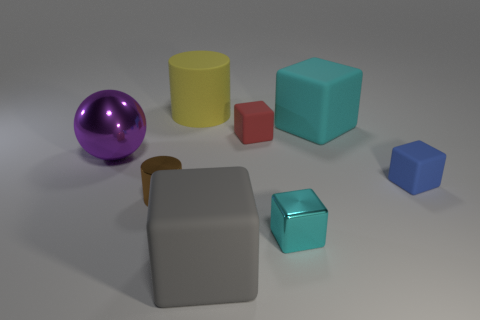There is a shiny thing that is the same shape as the blue rubber object; what is its color?
Make the answer very short. Cyan. Does the red thing on the right side of the big purple sphere have the same size as the cylinder that is in front of the big cylinder?
Your answer should be very brief. Yes. Are there any blue rubber things of the same shape as the gray thing?
Offer a very short reply. Yes. Is the number of yellow cylinders in front of the red object the same as the number of tiny blue rubber balls?
Keep it short and to the point. Yes. There is a red rubber thing; is its size the same as the cyan block that is in front of the shiny cylinder?
Your response must be concise. Yes. How many big things are made of the same material as the tiny cyan object?
Your response must be concise. 1. Do the red cube and the gray rubber thing have the same size?
Make the answer very short. No. Is there any other thing that is the same color as the metal cylinder?
Keep it short and to the point. No. What shape is the matte thing that is both on the right side of the cyan metal cube and in front of the large ball?
Provide a short and direct response. Cube. What is the size of the metallic object that is on the right side of the yellow cylinder?
Ensure brevity in your answer.  Small. 